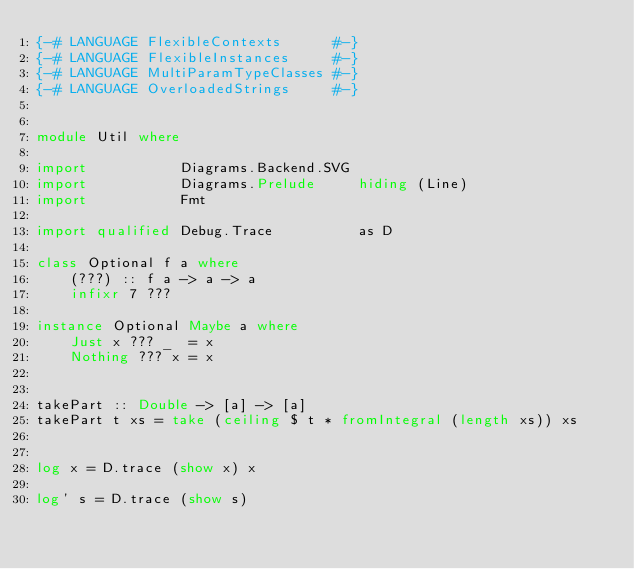Convert code to text. <code><loc_0><loc_0><loc_500><loc_500><_Haskell_>{-# LANGUAGE FlexibleContexts      #-}
{-# LANGUAGE FlexibleInstances     #-}
{-# LANGUAGE MultiParamTypeClasses #-}
{-# LANGUAGE OverloadedStrings     #-}


module Util where

import           Diagrams.Backend.SVG
import           Diagrams.Prelude     hiding (Line)
import           Fmt

import qualified Debug.Trace          as D

class Optional f a where
    (???) :: f a -> a -> a
    infixr 7 ???

instance Optional Maybe a where
    Just x ??? _  = x
    Nothing ??? x = x


takePart :: Double -> [a] -> [a]
takePart t xs = take (ceiling $ t * fromIntegral (length xs)) xs


log x = D.trace (show x) x

log' s = D.trace (show s)
</code> 